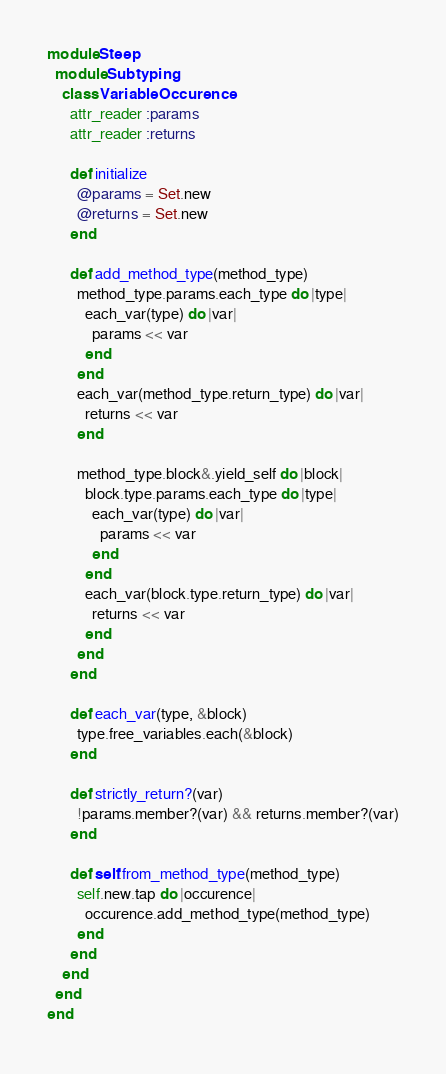Convert code to text. <code><loc_0><loc_0><loc_500><loc_500><_Ruby_>module Steep
  module Subtyping
    class VariableOccurence
      attr_reader :params
      attr_reader :returns

      def initialize
        @params = Set.new
        @returns = Set.new
      end

      def add_method_type(method_type)
        method_type.params.each_type do |type|
          each_var(type) do |var|
            params << var
          end
        end
        each_var(method_type.return_type) do |var|
          returns << var
        end

        method_type.block&.yield_self do |block|
          block.type.params.each_type do |type|
            each_var(type) do |var|
              params << var
            end
          end
          each_var(block.type.return_type) do |var|
            returns << var
          end
        end
      end

      def each_var(type, &block)
        type.free_variables.each(&block)
      end

      def strictly_return?(var)
        !params.member?(var) && returns.member?(var)
      end

      def self.from_method_type(method_type)
        self.new.tap do |occurence|
          occurence.add_method_type(method_type)
        end
      end
    end
  end
end
</code> 